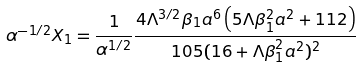<formula> <loc_0><loc_0><loc_500><loc_500>\alpha ^ { - 1 / 2 } X _ { 1 } = \frac { 1 } { \alpha ^ { 1 / 2 } } \frac { 4 \Lambda ^ { 3 / 2 } \beta _ { 1 } a ^ { 6 } \left ( 5 \Lambda \beta _ { 1 } ^ { 2 } a ^ { 2 } + 1 1 2 \right ) } { 1 0 5 ( 1 6 + \Lambda \beta _ { 1 } ^ { 2 } a ^ { 2 } ) ^ { 2 } }</formula> 